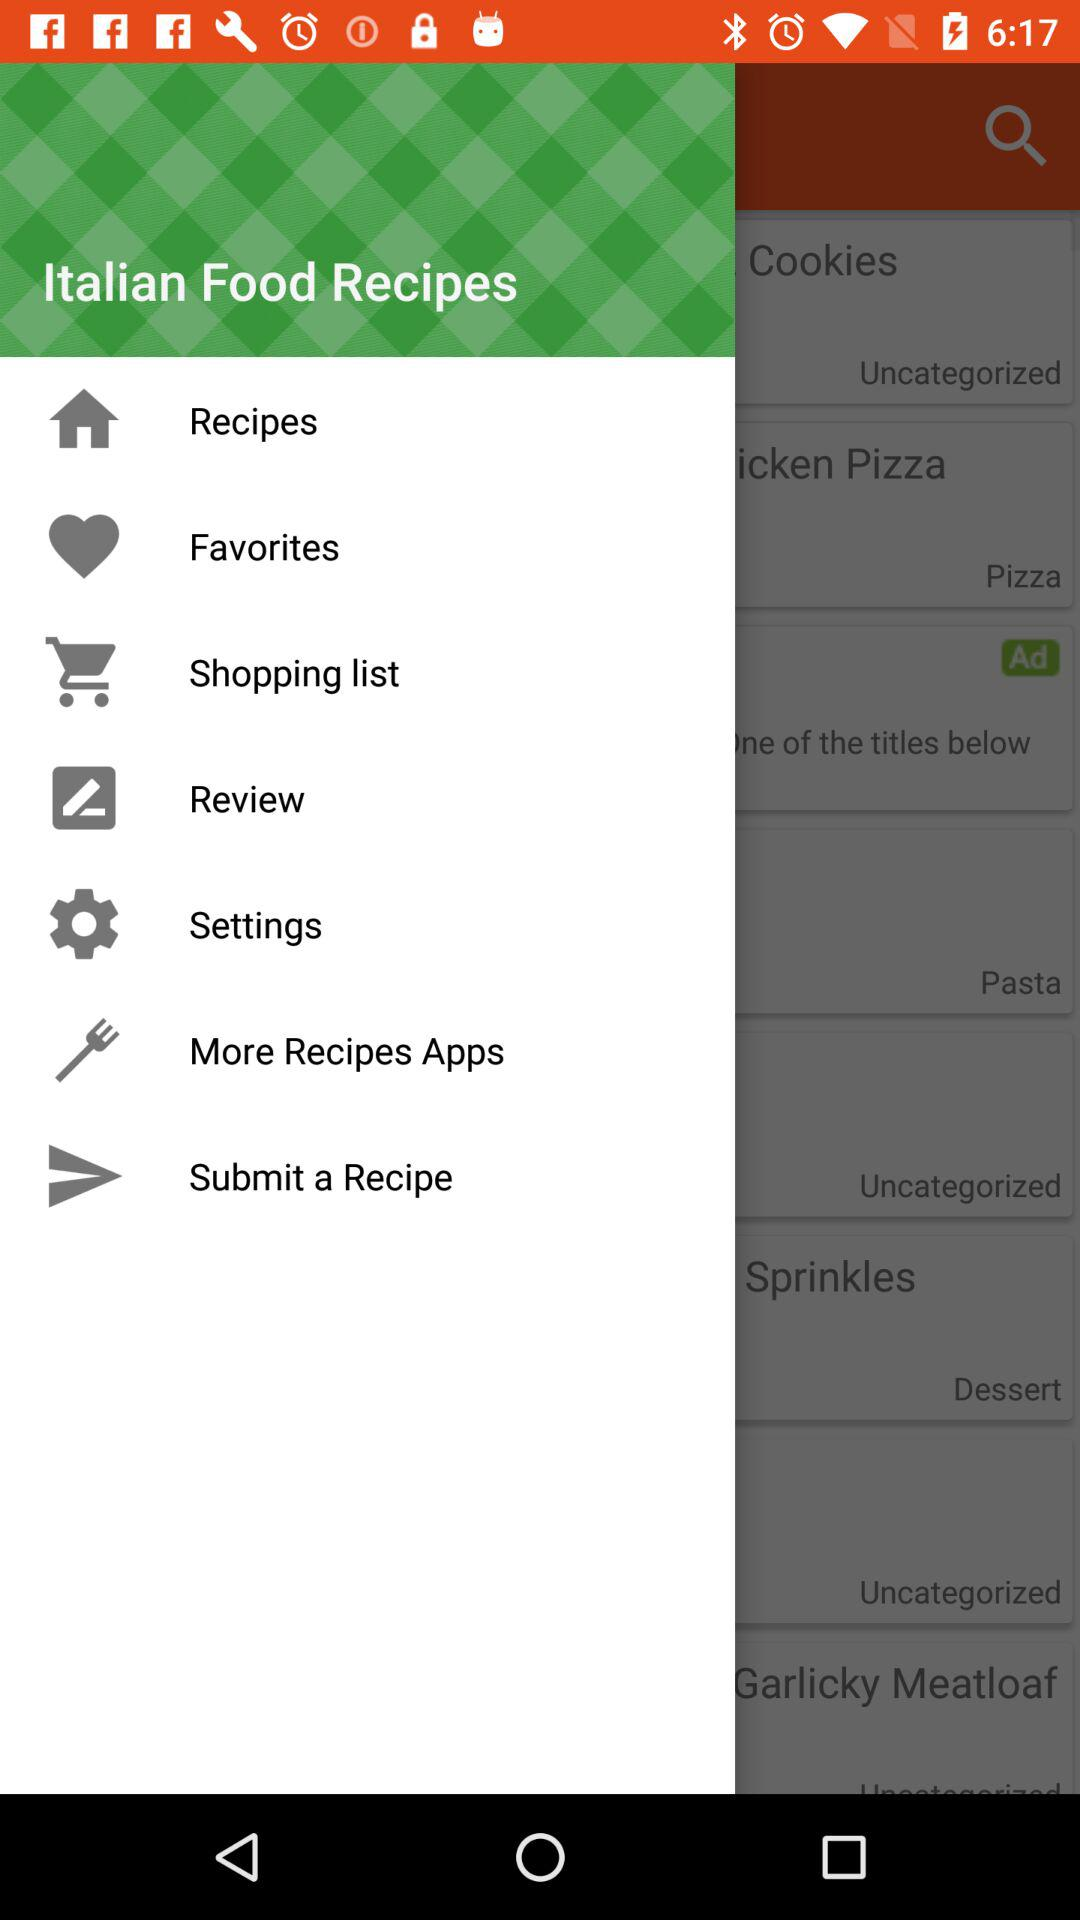What is the name of the application? The application name is "Italian Food Recipes". 